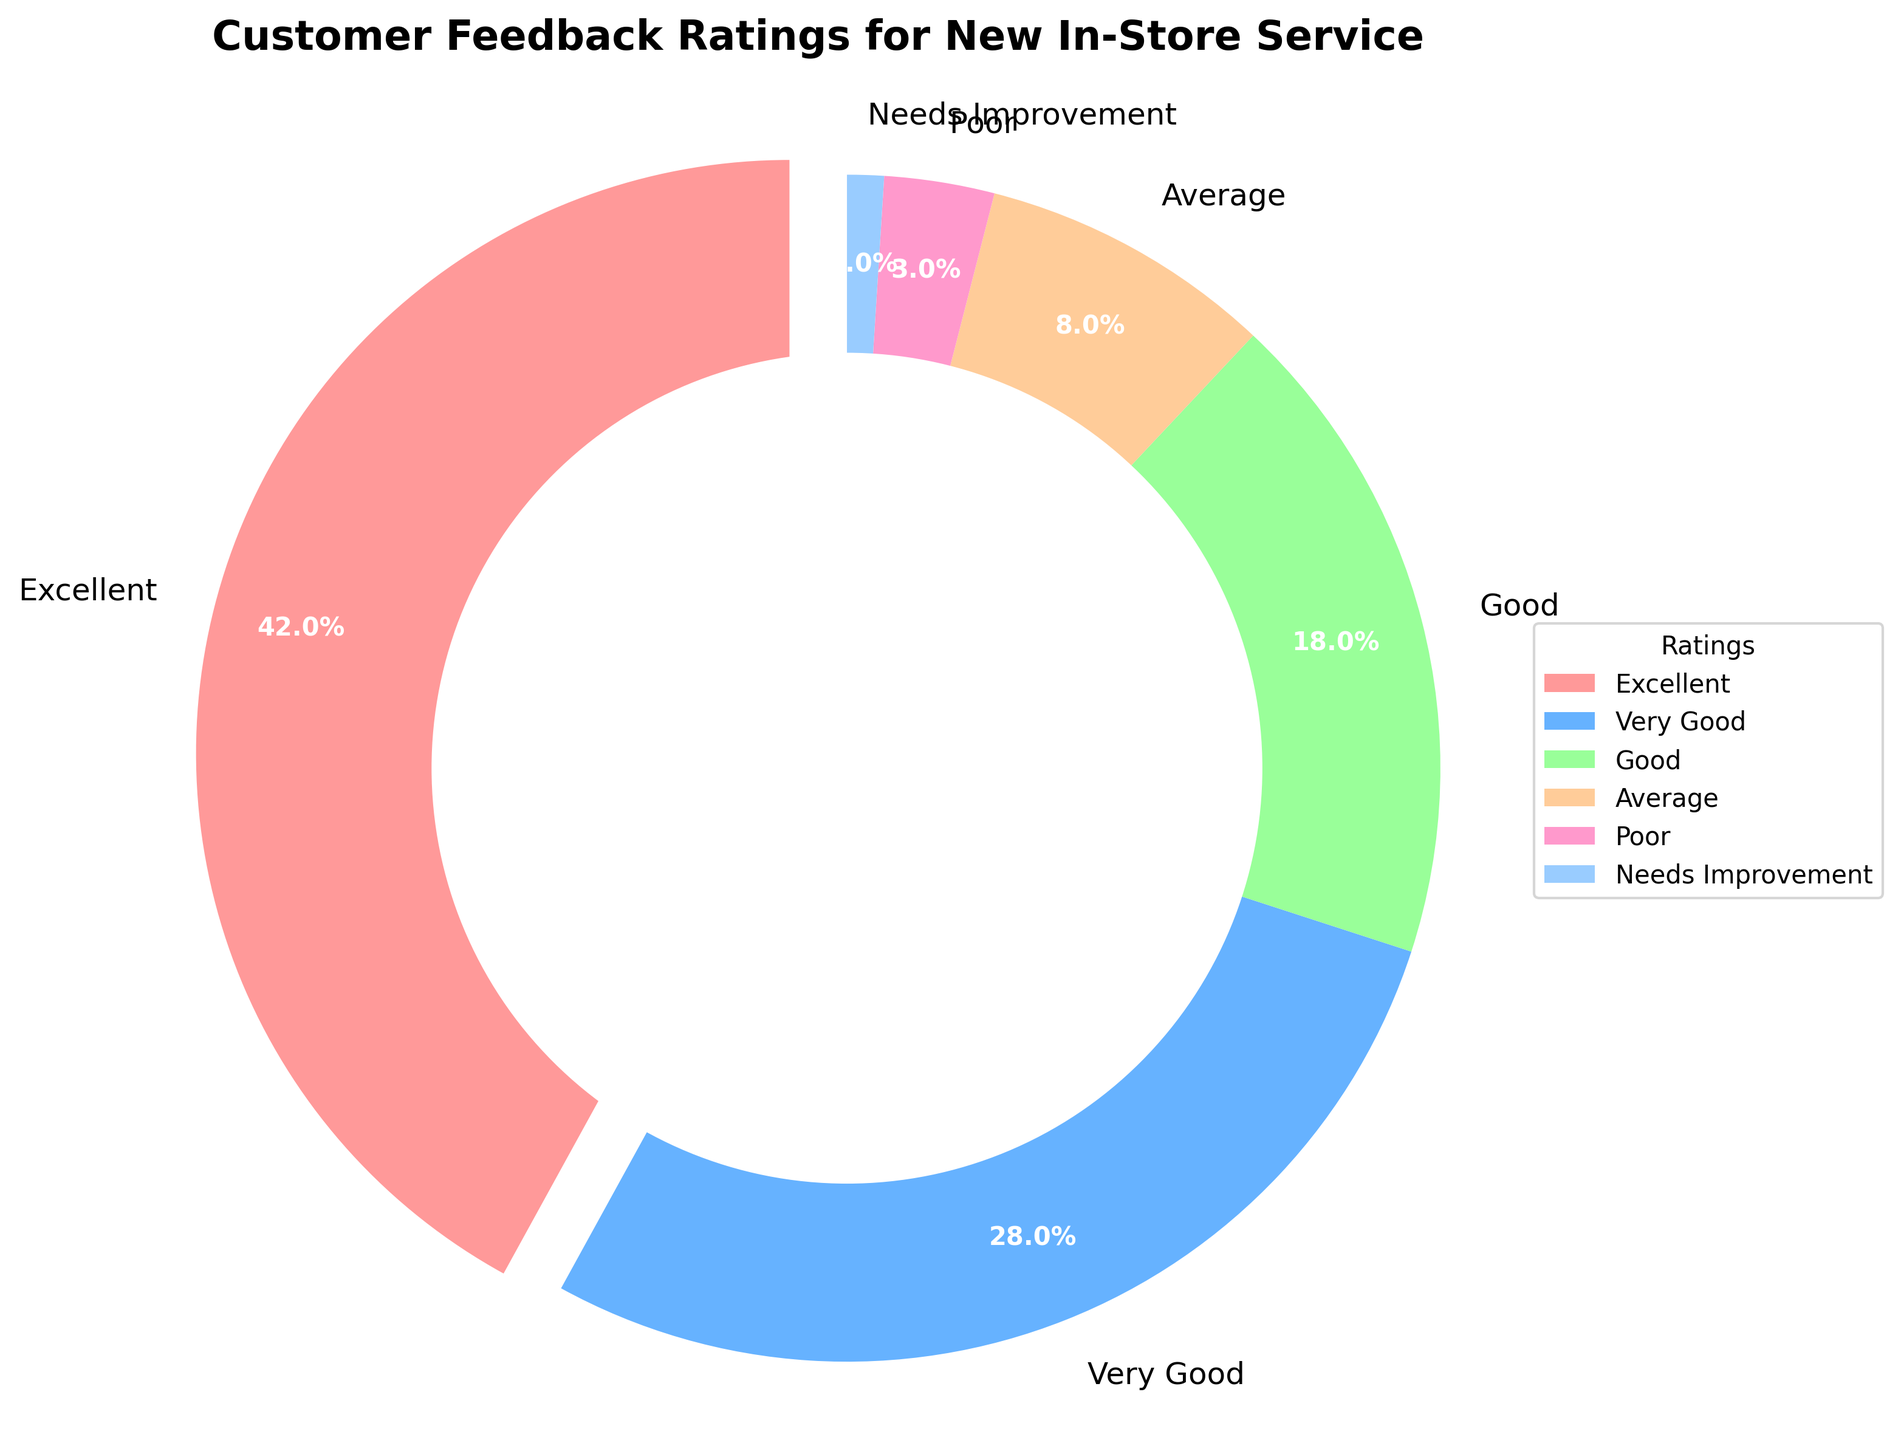What's the percentage of customers who rated the service as "Poor"? Based on the pie chart, you can locate the label "Poor" and see the percentage associated with it.
Answer: 3% How many customers rated the service as "Excellent" and "Very Good" combined? To find the combined percentage of customers who rated "Excellent" and "Very Good", you add the percentages for both categories, i.e., 42% + 28%
Answer: 70% Which rating category had the smallest percentage of customers? By observing the pie chart, you can identify that the smallest slice corresponds to the "Needs Improvement" category.
Answer: Needs Improvement How does the percentage of "Good" ratings compare to "Average" ratings? To compare these categories, you simply check their respective percentages on the pie chart. "Good" is 18% and "Average" is 8%. Thus, "Good" has a higher percentage.
Answer: Good ratings have a higher percentage What is the difference between the highest and the lowest percentage ratings? The highest percentage rating is "Excellent" at 42%, and the lowest is "Needs Improvement" at 1%. The difference is 42% - 1%.
Answer: 41% What proportion of the ratings are below "Very Good"? Summing up the percentages of "Good", "Average", "Poor", and "Needs Improvement" gives 18% + 8% + 3% + 1%.
Answer: 30% If 1000 customers provided feedback, how many rated the service as "Excellent"? If 42% of 1000 customers rated the service as "Excellent", then you calculate 42% of 1000. This equals 0.42 * 1000.
Answer: 420 Are there more "Excellent" ratings than the combined total of "Average" and "Poor" ratings? Comparing the percentages: "Excellent" is 42%, while the combined percentage for "Average" and "Poor" is 8% + 3%. Since 42% > 11%, there are indeed more "Excellent" ratings.
Answer: Yes Which rating is displayed using the light green color? By inspecting the visual colors assigned to different rating categories, you observe the light green color is associated with the "Good" rating.
Answer: Good 